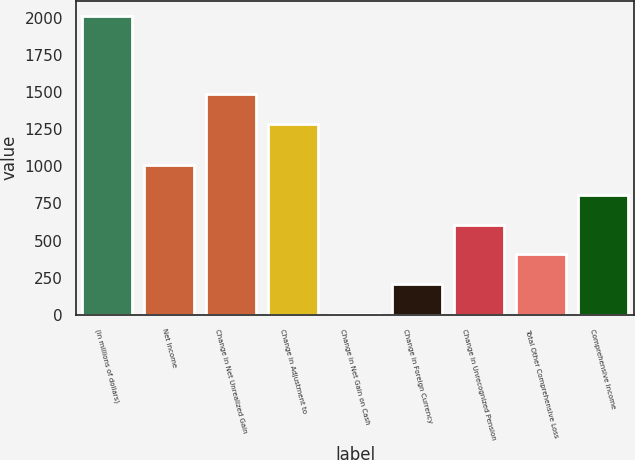Convert chart to OTSL. <chart><loc_0><loc_0><loc_500><loc_500><bar_chart><fcel>(in millions of dollars)<fcel>Net Income<fcel>Change in Net Unrealized Gain<fcel>Change in Adjustment to<fcel>Change in Net Gain on Cash<fcel>Change in Foreign Currency<fcel>Change in Unrecognized Pension<fcel>Total Other Comprehensive Loss<fcel>Comprehensive Income<nl><fcel>2014<fcel>1009.65<fcel>1485.57<fcel>1284.7<fcel>5.3<fcel>206.17<fcel>607.91<fcel>407.04<fcel>808.78<nl></chart> 